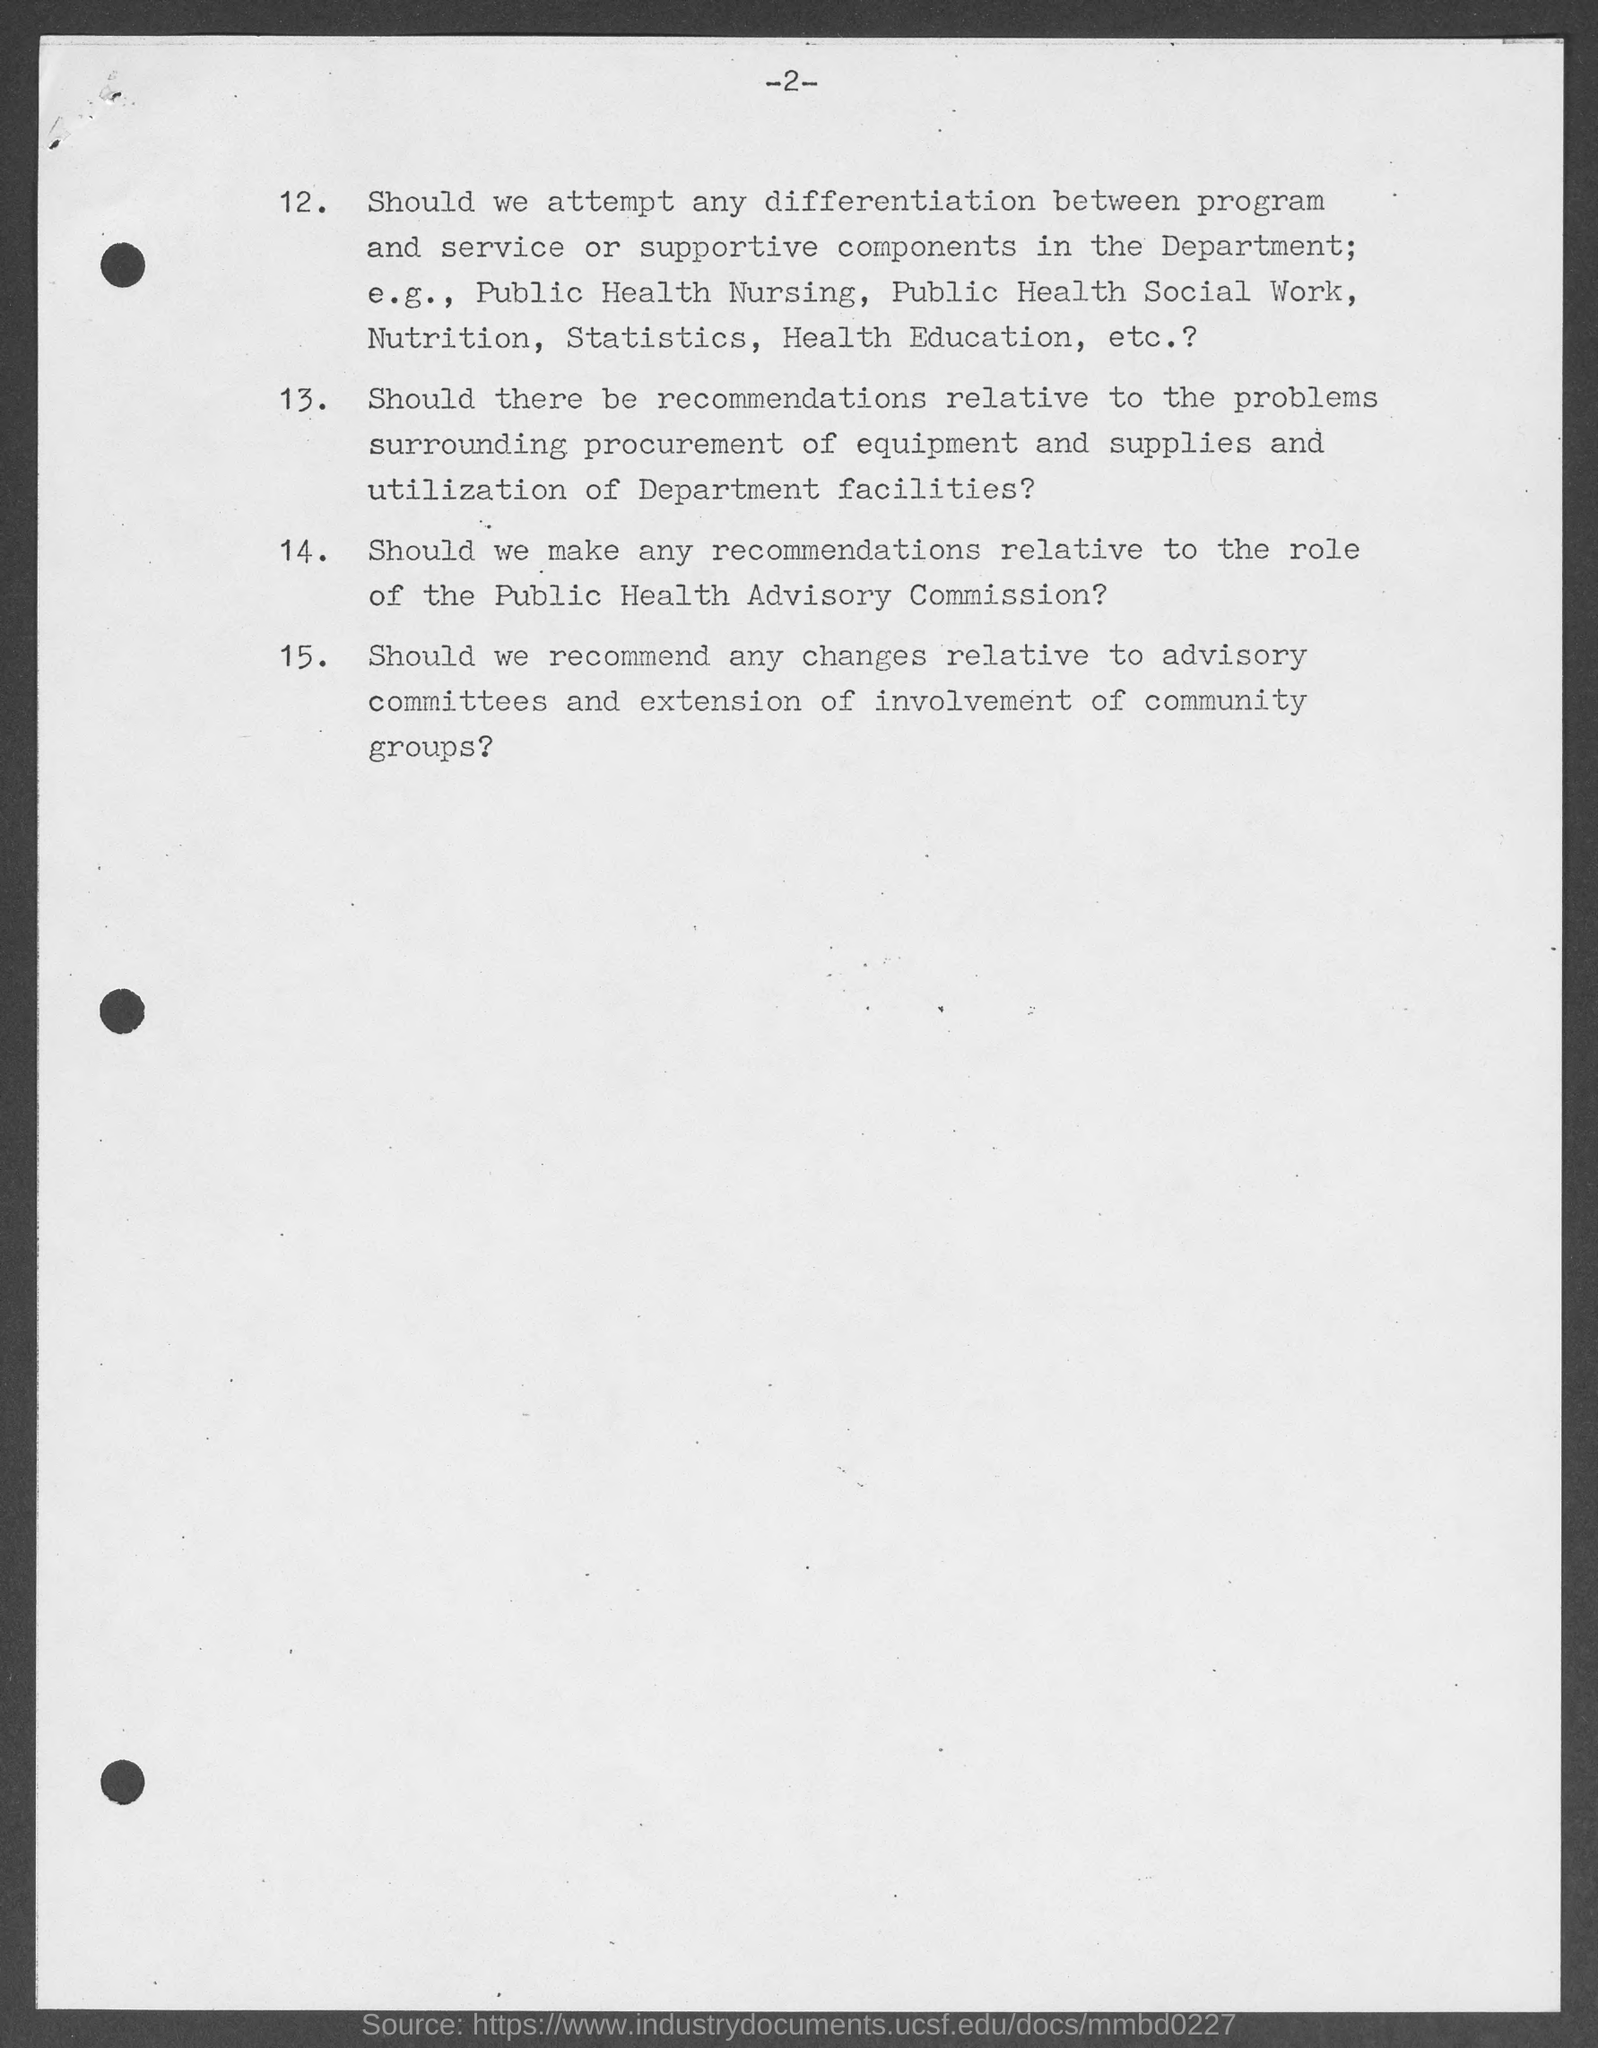Point out several critical features in this image. The page number mentioned in this document is 2. 